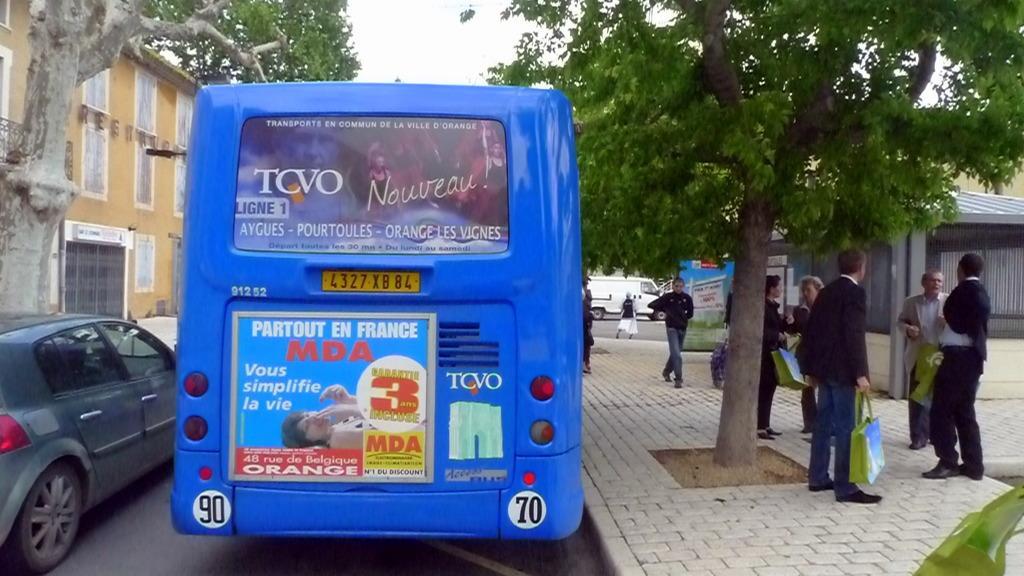Can you describe this image briefly? This image is clicked on the roads. On the right, there are many people standing on the pavement. In the front, we can see a bus and a car on the road. On the left, there is a building. On the left and right, there are trees. At the top, there is a sky. On the extreme right, there is a shed. 